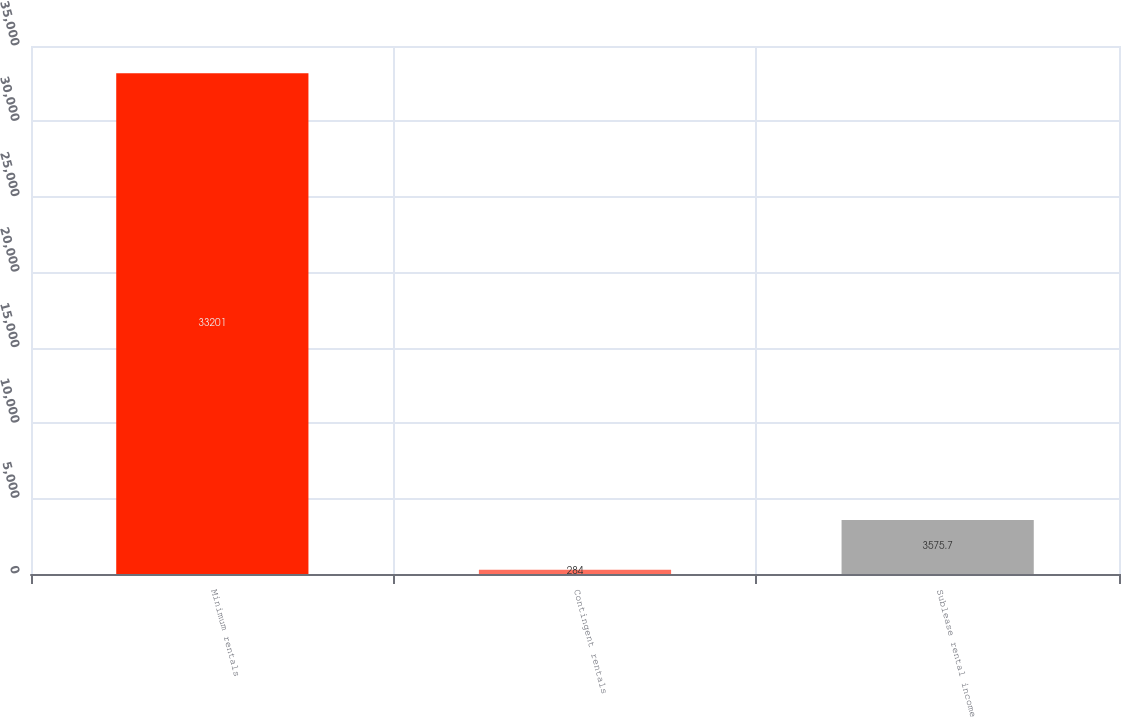Convert chart. <chart><loc_0><loc_0><loc_500><loc_500><bar_chart><fcel>Minimum rentals<fcel>Contingent rentals<fcel>Sublease rental income<nl><fcel>33201<fcel>284<fcel>3575.7<nl></chart> 